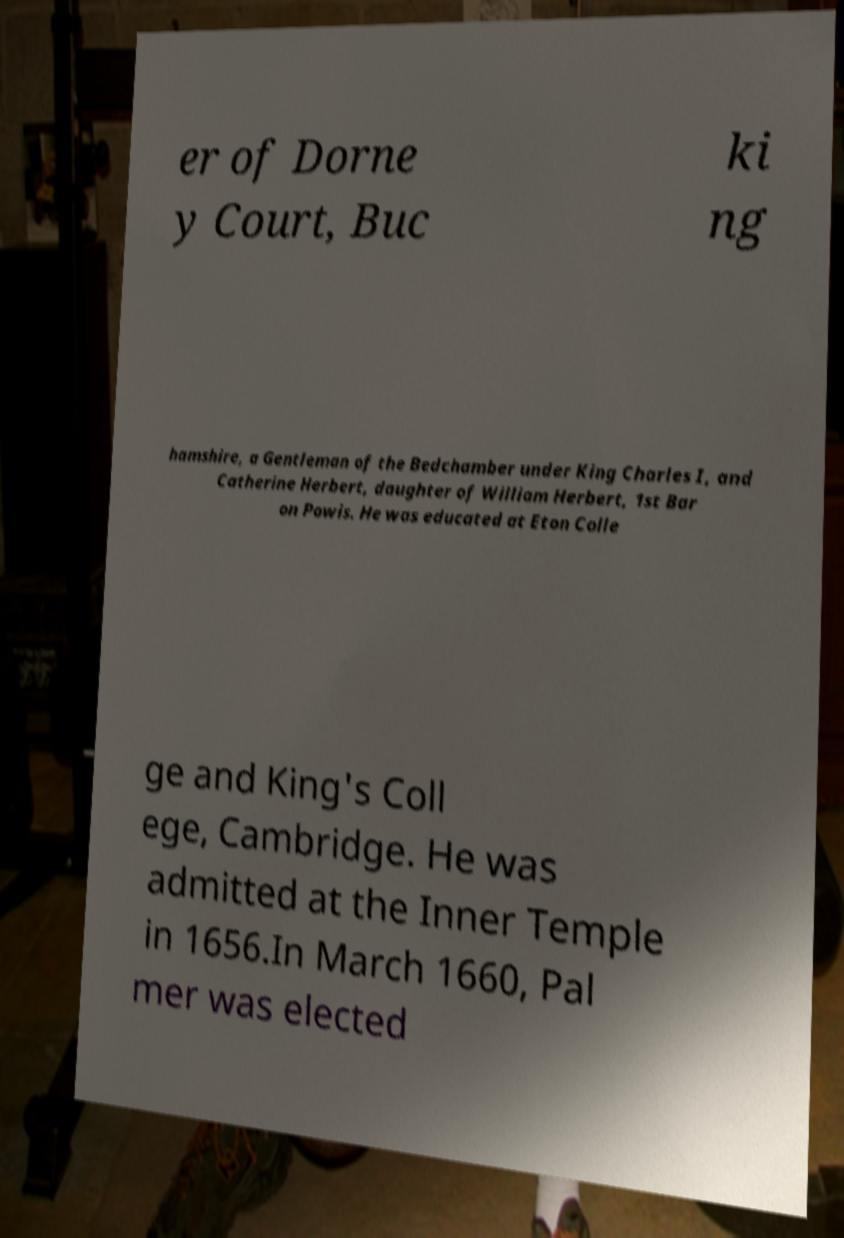Can you read and provide the text displayed in the image?This photo seems to have some interesting text. Can you extract and type it out for me? er of Dorne y Court, Buc ki ng hamshire, a Gentleman of the Bedchamber under King Charles I, and Catherine Herbert, daughter of William Herbert, 1st Bar on Powis. He was educated at Eton Colle ge and King's Coll ege, Cambridge. He was admitted at the Inner Temple in 1656.In March 1660, Pal mer was elected 